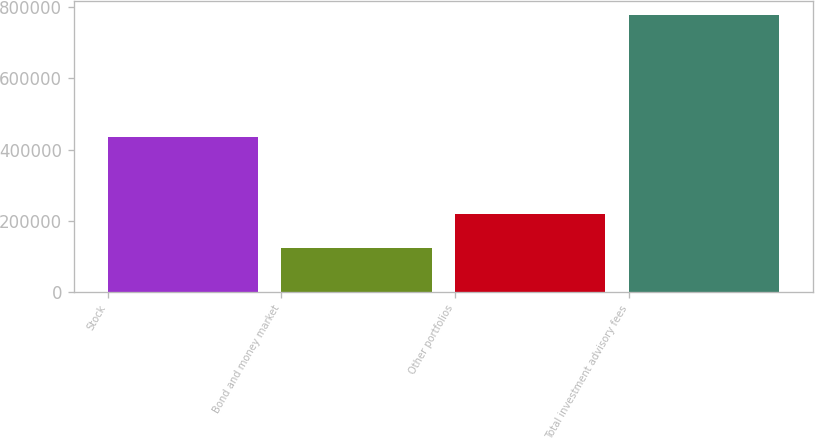<chart> <loc_0><loc_0><loc_500><loc_500><bar_chart><fcel>Stock<fcel>Bond and money market<fcel>Other portfolios<fcel>Total investment advisory fees<nl><fcel>434423<fcel>123879<fcel>219160<fcel>777462<nl></chart> 